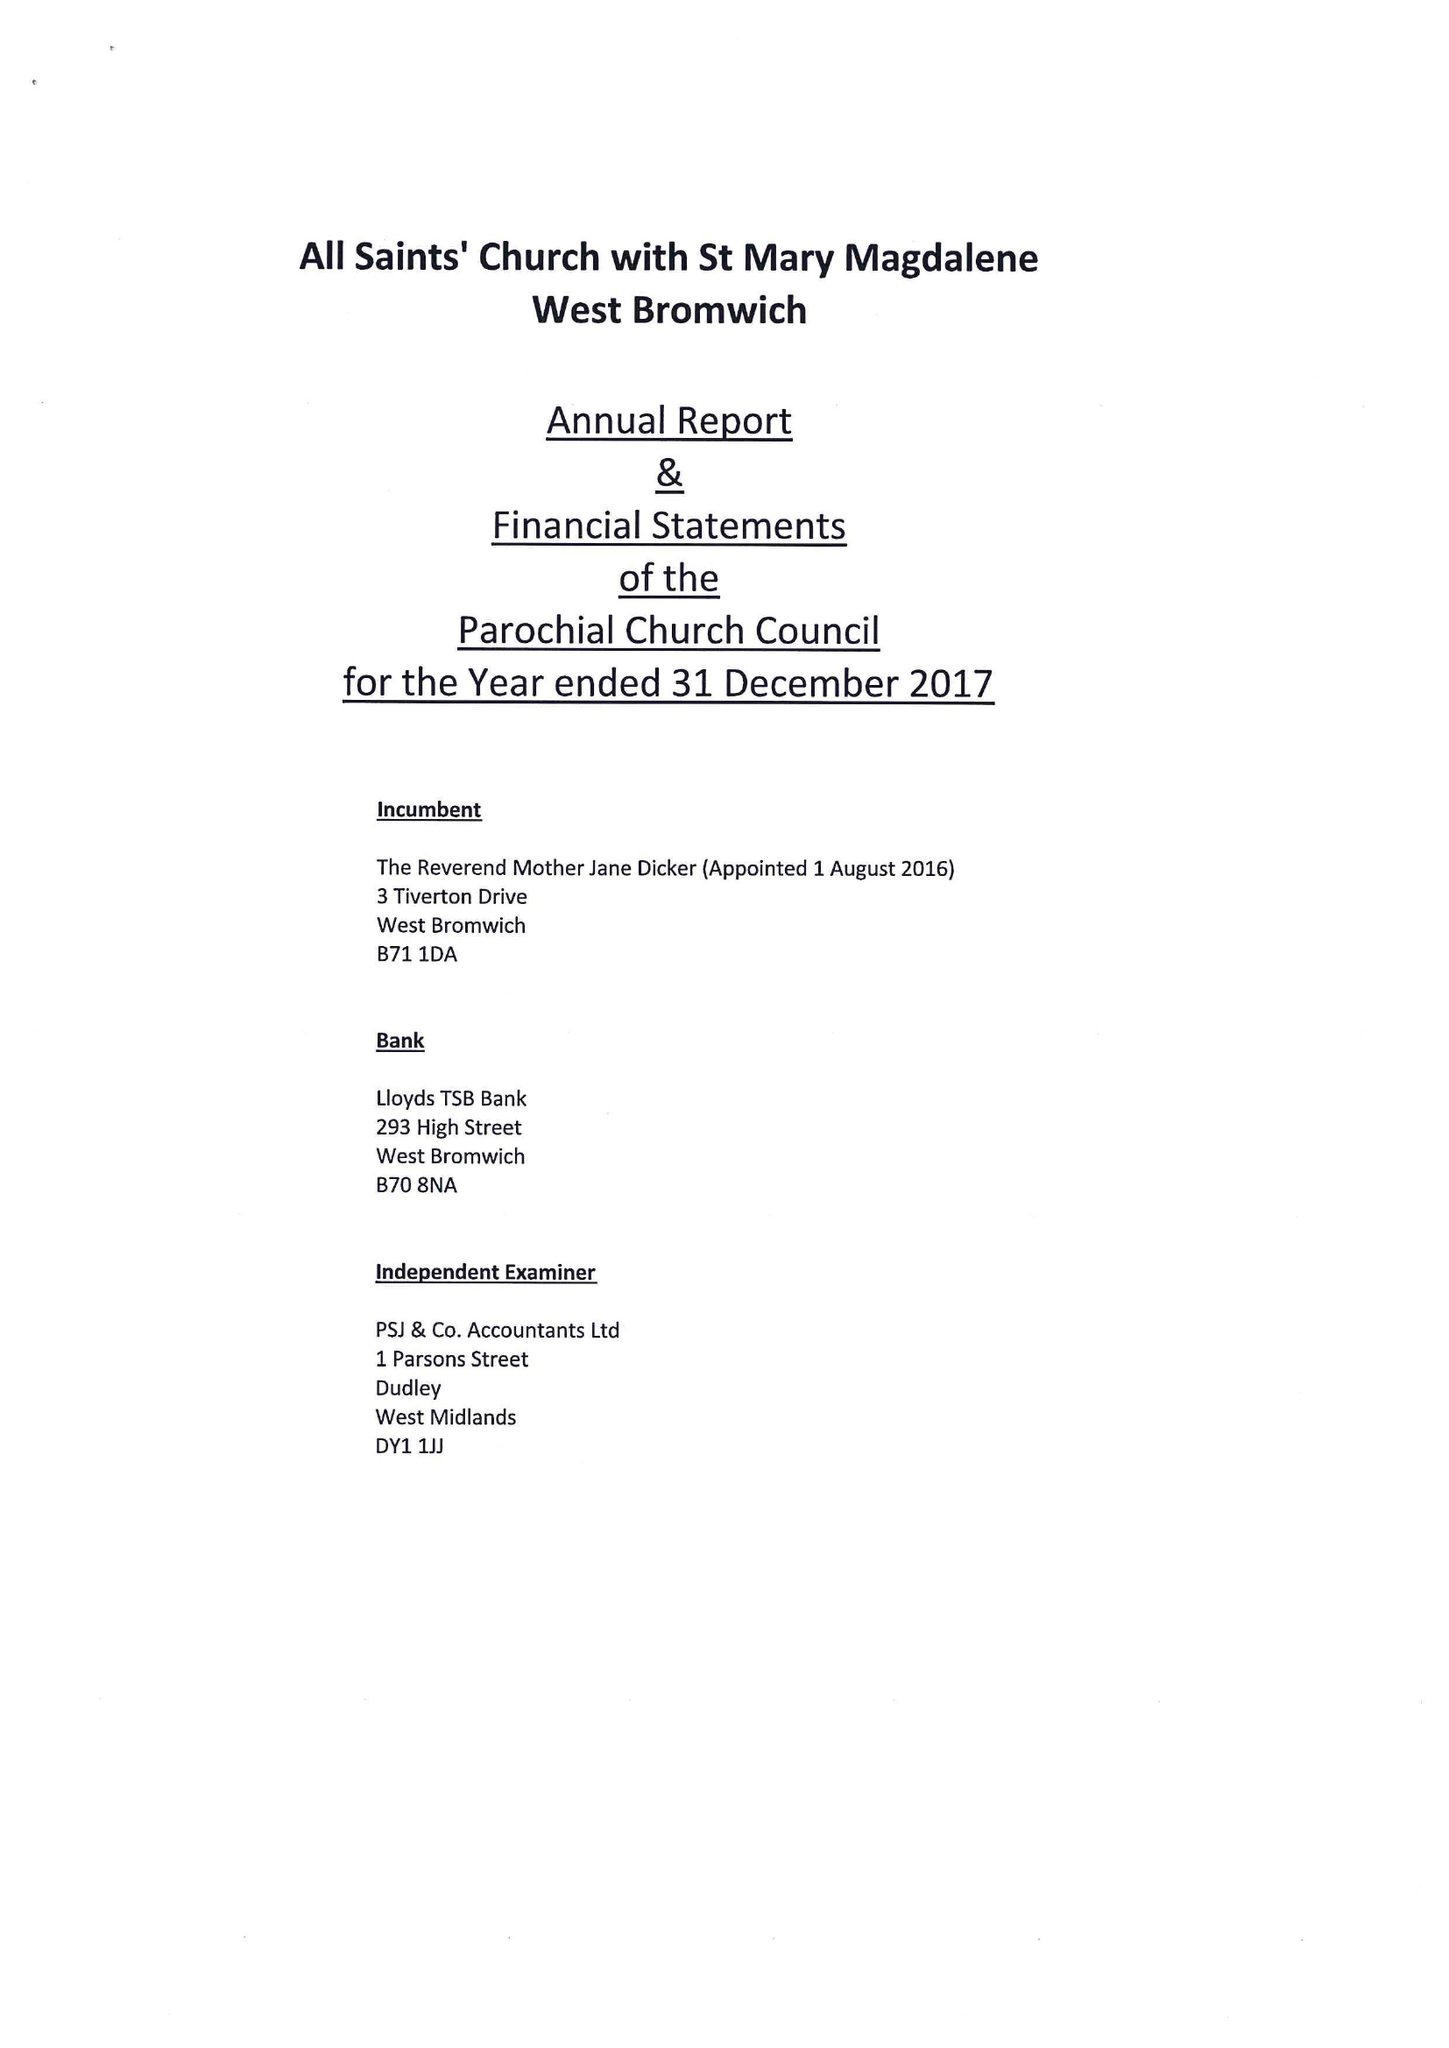What is the value for the report_date?
Answer the question using a single word or phrase. 2017-12-31 